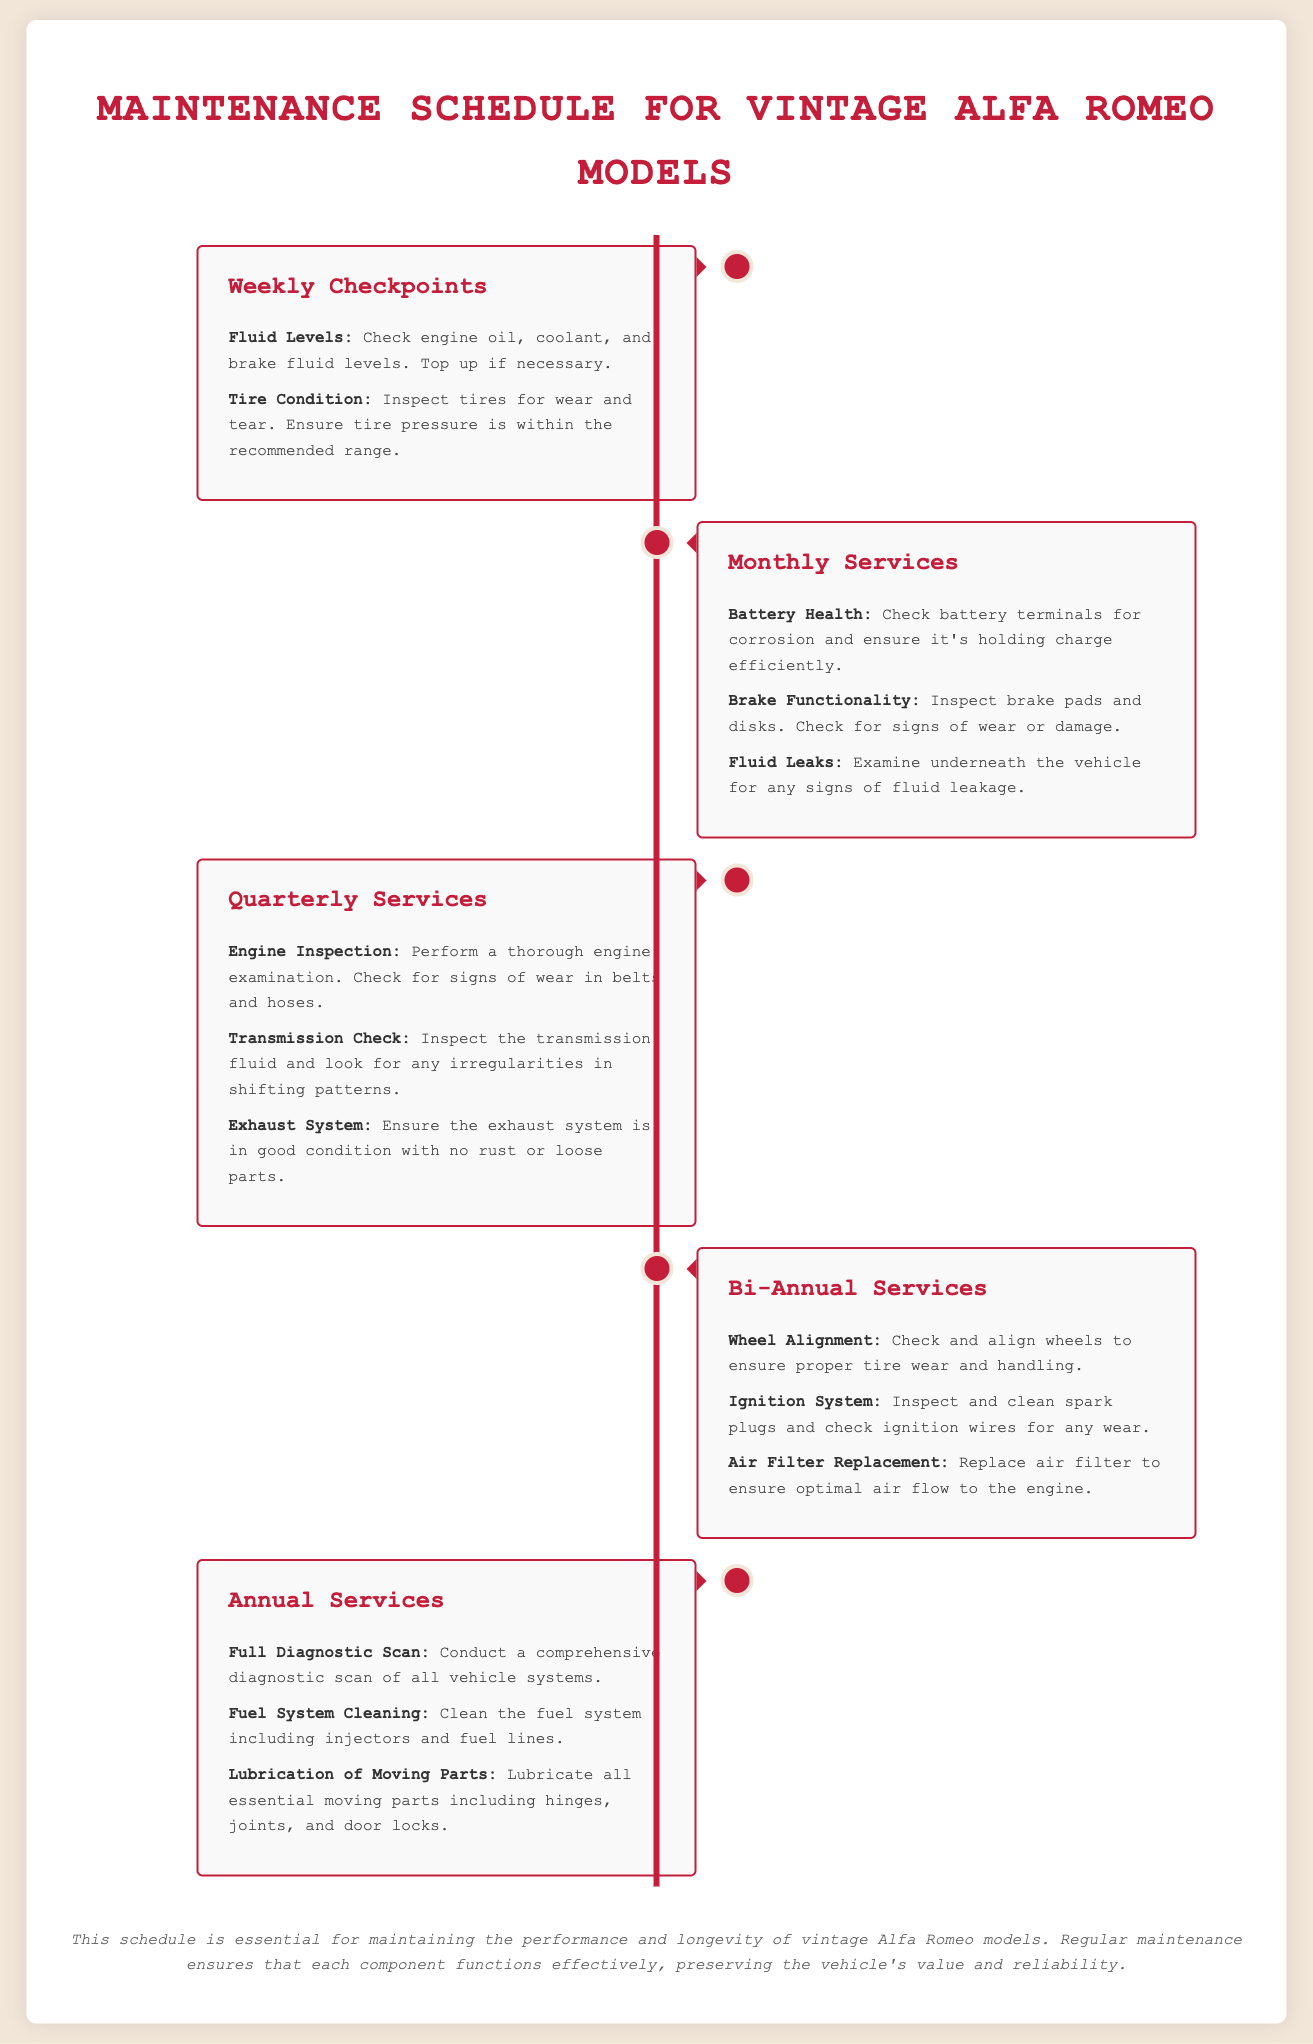what is the title of the infographic? The title of the infographic is found at the top of the document, summarizing its content.
Answer: Maintenance Schedule for Vintage Alfa Romeo Models how often should battery health be checked? The document specifies the frequency of checking battery health under monthly services.
Answer: Monthly what is one checkpoint to inspect weekly? The infographic lists specific checkpoints to verify on a weekly basis.
Answer: Fluid Levels which service involves checking exhaust system conditions? The quarterly services detail various inspections, including one related to the exhaust system.
Answer: Quarterly Services how many items are listed under annual services? Counting the items mentioned under annual services provides this total.
Answer: Three what maintenance action should be taken bi-annually? The infographic outlines specific actions to be taken twice a year, one of which is an alignment procedure.
Answer: Wheel Alignment what color is used for section headings? The document specifies the font color for headings, providing a consistent design theme.
Answer: #c41e3a which two components are checked in the quarterly services? The quarterly services section lists multiple components and actions for checks, combining two for the answer.
Answer: Engine Inspection and Transmission Check what is highlighted as essential to maintain vintage Alfa Romeo models? The infographic ends with a note summarizing the importance of a specific maintenance approach.
Answer: Regular maintenance 